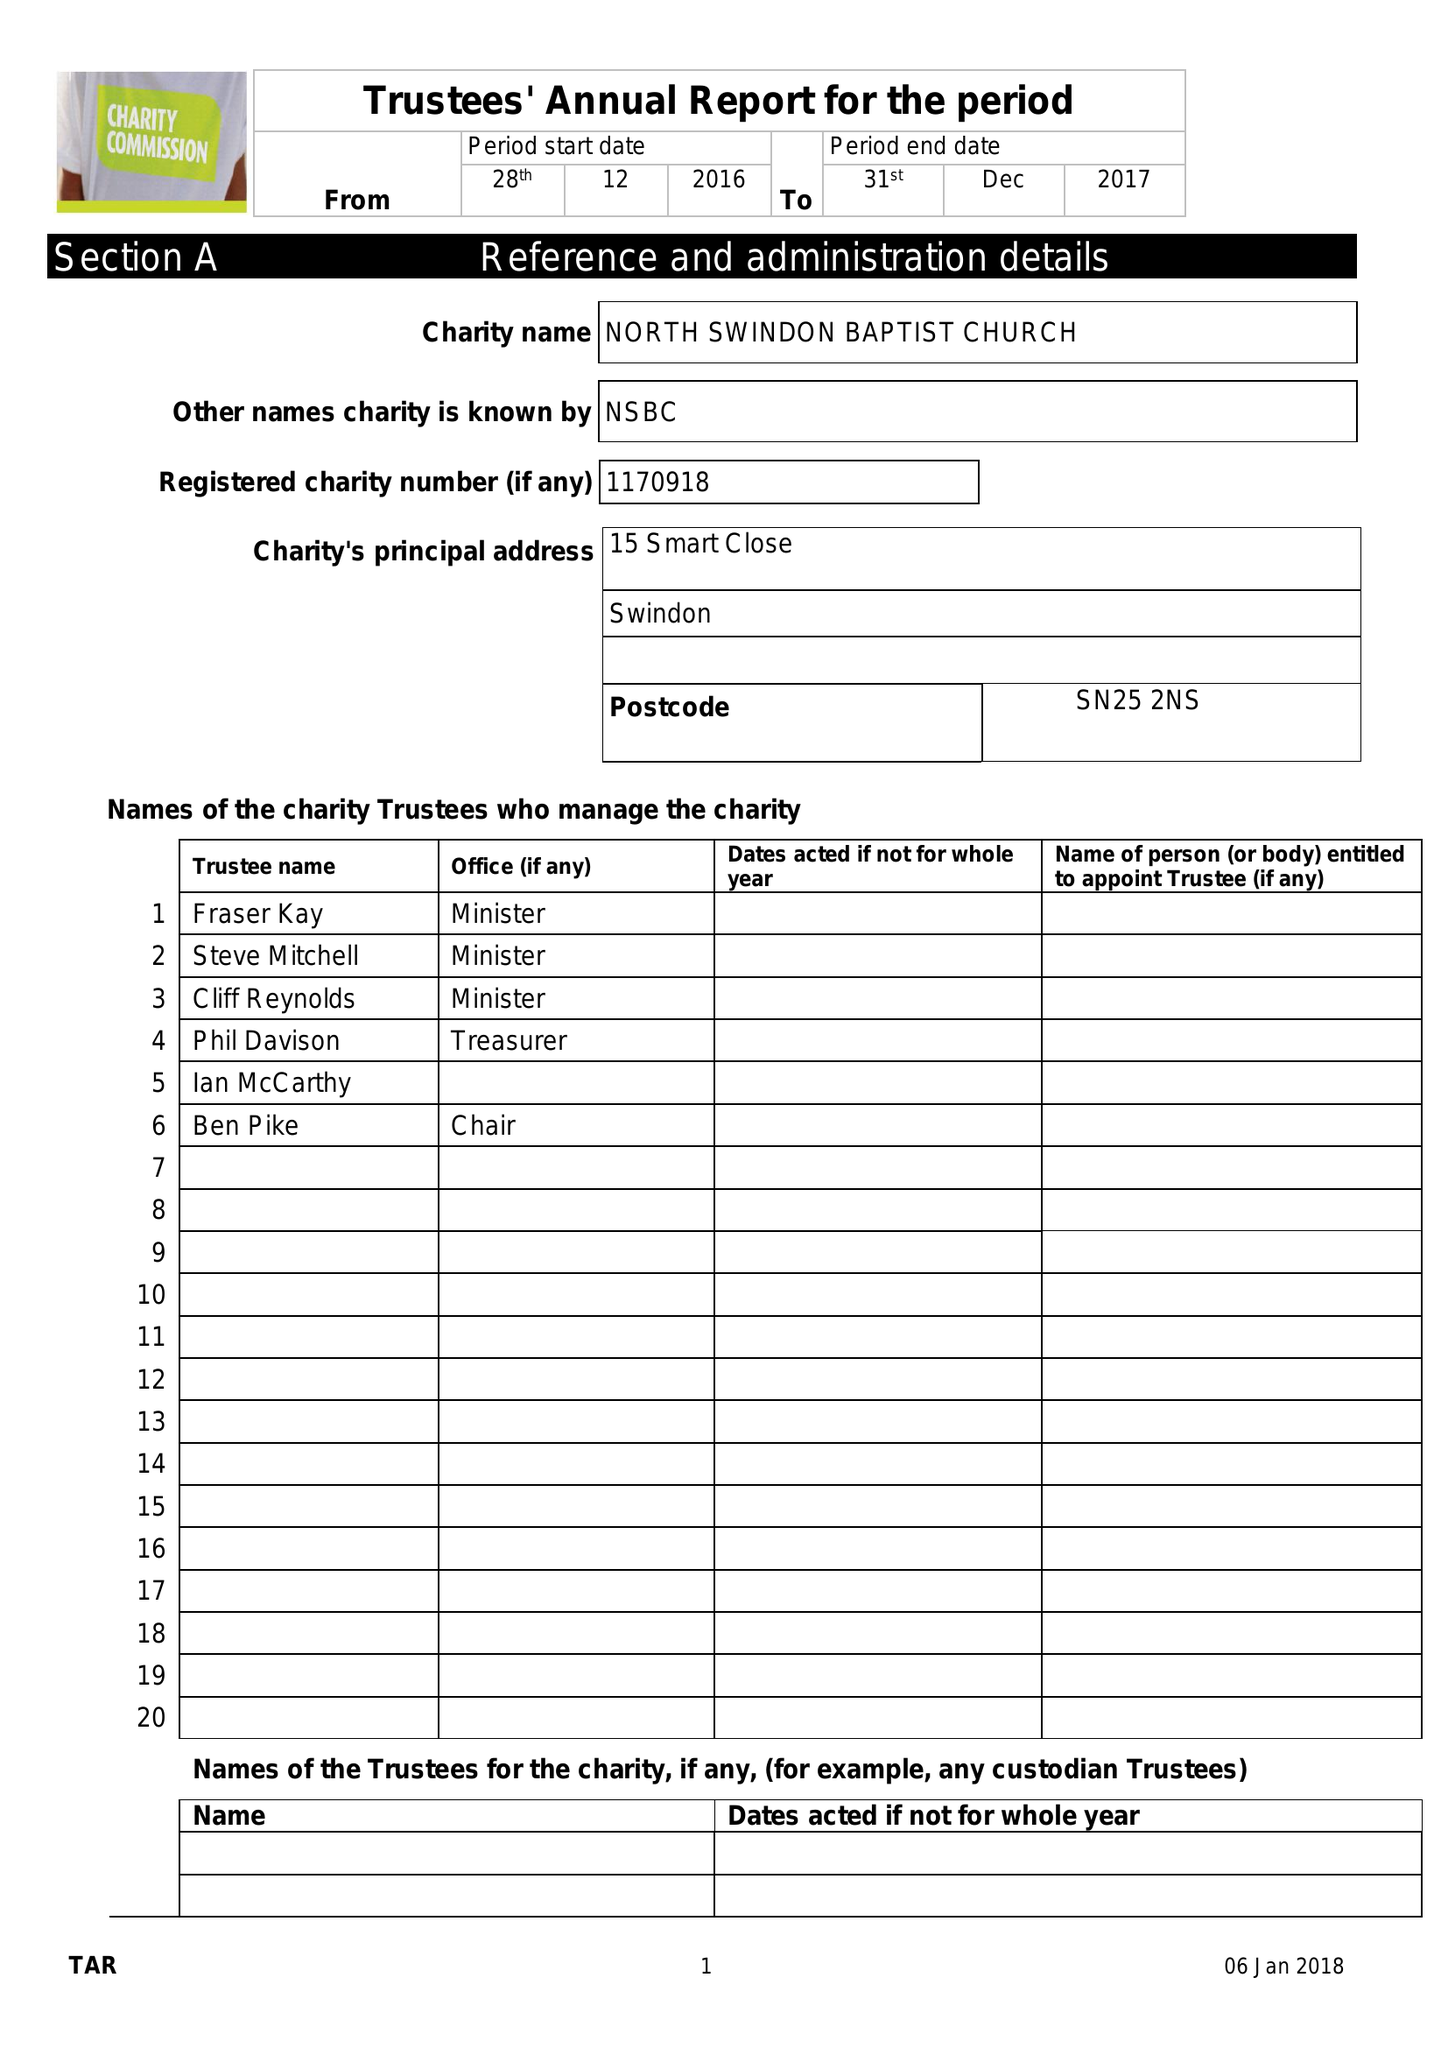What is the value for the address__postcode?
Answer the question using a single word or phrase. SN25 2NS 